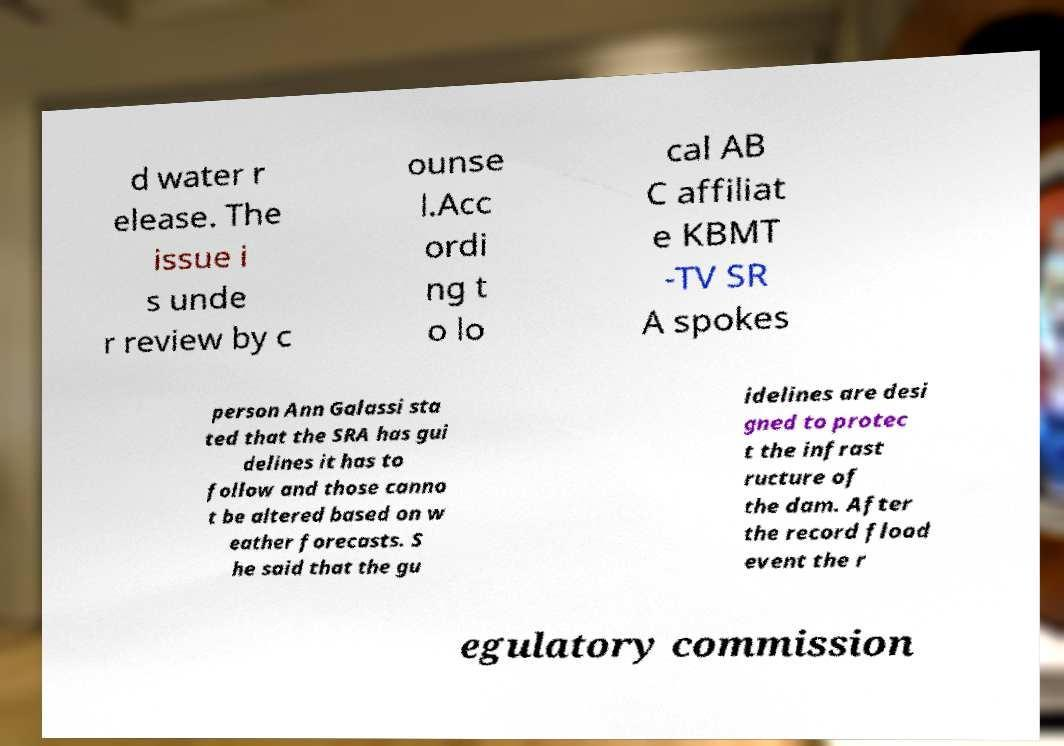Can you read and provide the text displayed in the image?This photo seems to have some interesting text. Can you extract and type it out for me? d water r elease. The issue i s unde r review by c ounse l.Acc ordi ng t o lo cal AB C affiliat e KBMT -TV SR A spokes person Ann Galassi sta ted that the SRA has gui delines it has to follow and those canno t be altered based on w eather forecasts. S he said that the gu idelines are desi gned to protec t the infrast ructure of the dam. After the record flood event the r egulatory commission 